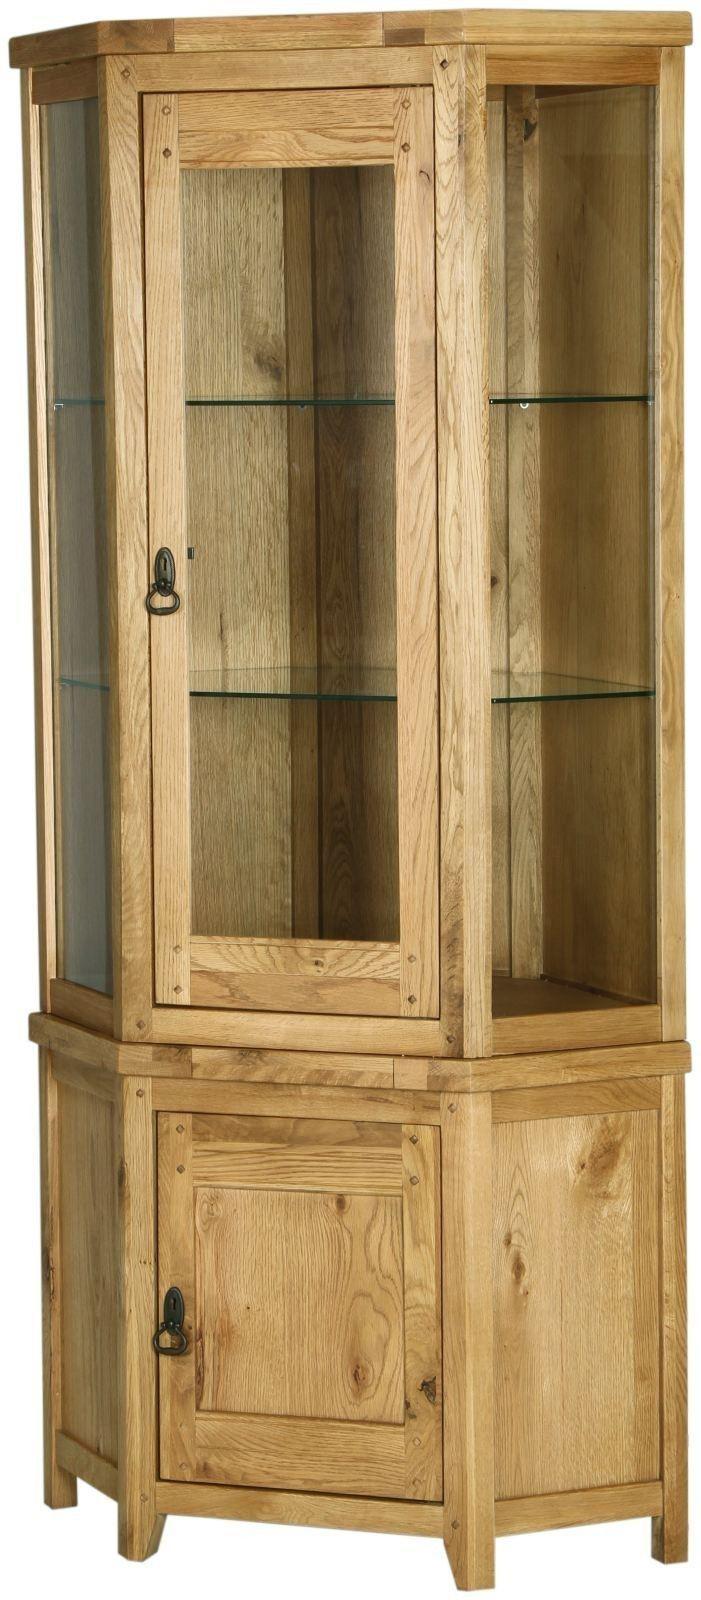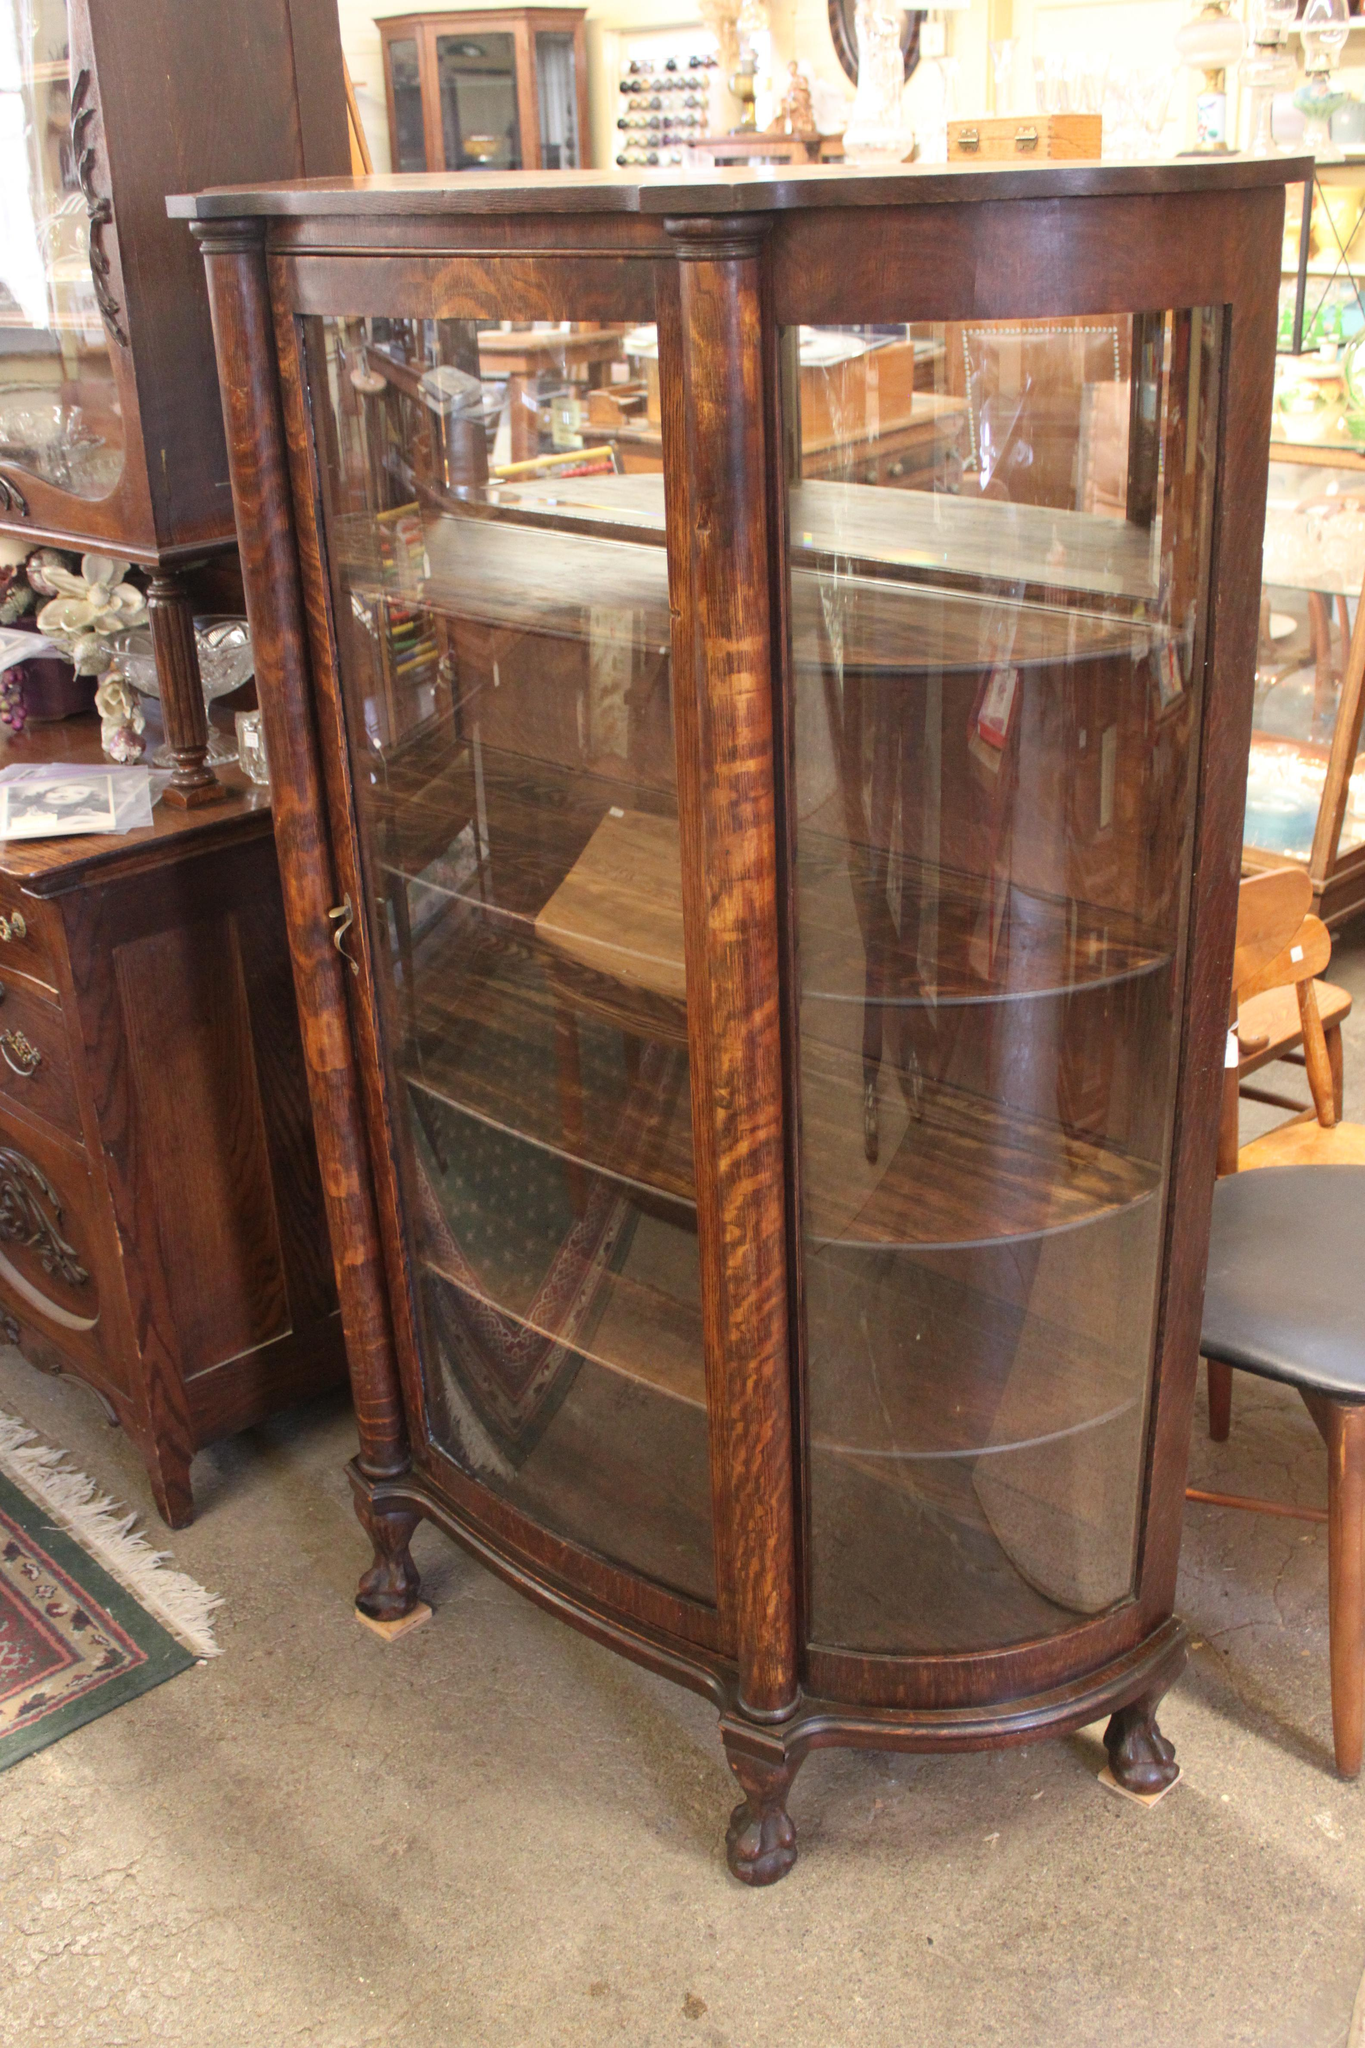The first image is the image on the left, the second image is the image on the right. Assess this claim about the two images: "All images show a piece of furniture with drawers". Correct or not? Answer yes or no. No. 